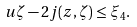Convert formula to latex. <formula><loc_0><loc_0><loc_500><loc_500>u \zeta - 2 j ( z , \zeta ) \leq \xi _ { 4 } .</formula> 